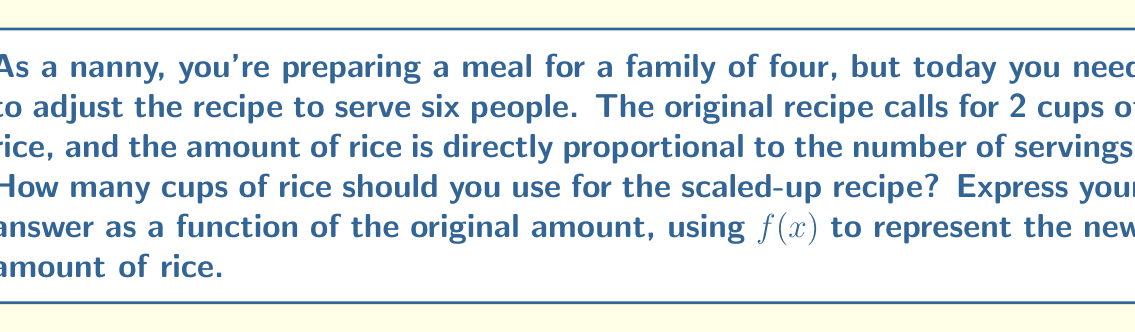Can you answer this question? Let's approach this step-by-step:

1) First, we need to identify the scaling factor. We're increasing the servings from 4 to 6.
   Scaling factor = $\frac{\text{New number of servings}}{\text{Original number of servings}} = \frac{6}{4} = 1.5$

2) In function notation, we can represent this scaling as a transformation of the original function.
   If $x$ represents the original amount of an ingredient, then $f(x) = 1.5x$ will give us the new amount.

3) To verify, let's plug in the original amount of rice:
   $f(2) = 1.5 \cdot 2 = 3$

4) This means we need 3 cups of rice for 6 servings, which makes sense as it's 1.5 times the original amount.

5) Therefore, the function $f(x) = 1.5x$ correctly represents how to scale any ingredient in the recipe for 6 servings instead of 4.
Answer: $f(x) = 1.5x$ 